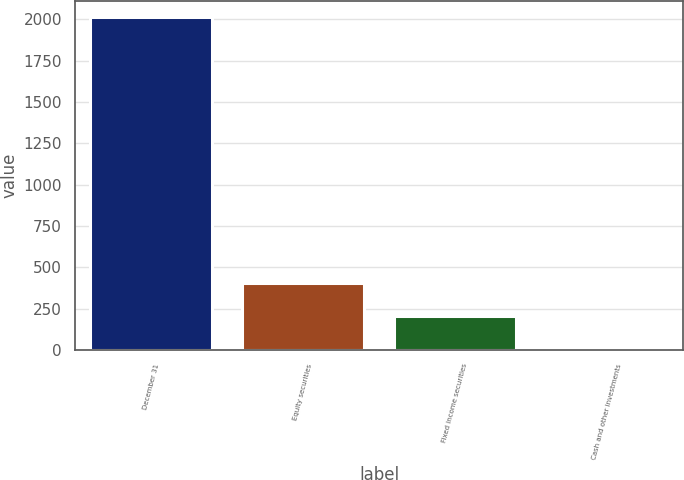<chart> <loc_0><loc_0><loc_500><loc_500><bar_chart><fcel>December 31<fcel>Equity securities<fcel>Fixed income securities<fcel>Cash and other investments<nl><fcel>2012<fcel>403.2<fcel>202.1<fcel>1<nl></chart> 